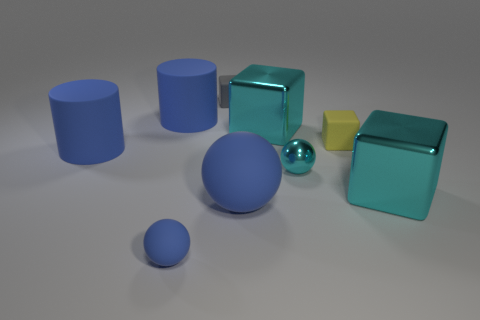Subtract all cyan balls. How many balls are left? 2 Subtract all gray spheres. How many green cylinders are left? 0 Subtract all blue metal balls. Subtract all blue rubber balls. How many objects are left? 7 Add 7 yellow cubes. How many yellow cubes are left? 8 Add 3 large metallic things. How many large metallic things exist? 5 Subtract all cyan cubes. How many cubes are left? 2 Subtract 1 cyan spheres. How many objects are left? 8 Subtract all cylinders. How many objects are left? 7 Subtract 3 cubes. How many cubes are left? 1 Subtract all yellow cubes. Subtract all purple cylinders. How many cubes are left? 3 